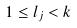Convert formula to latex. <formula><loc_0><loc_0><loc_500><loc_500>1 \leq l _ { j } < k</formula> 